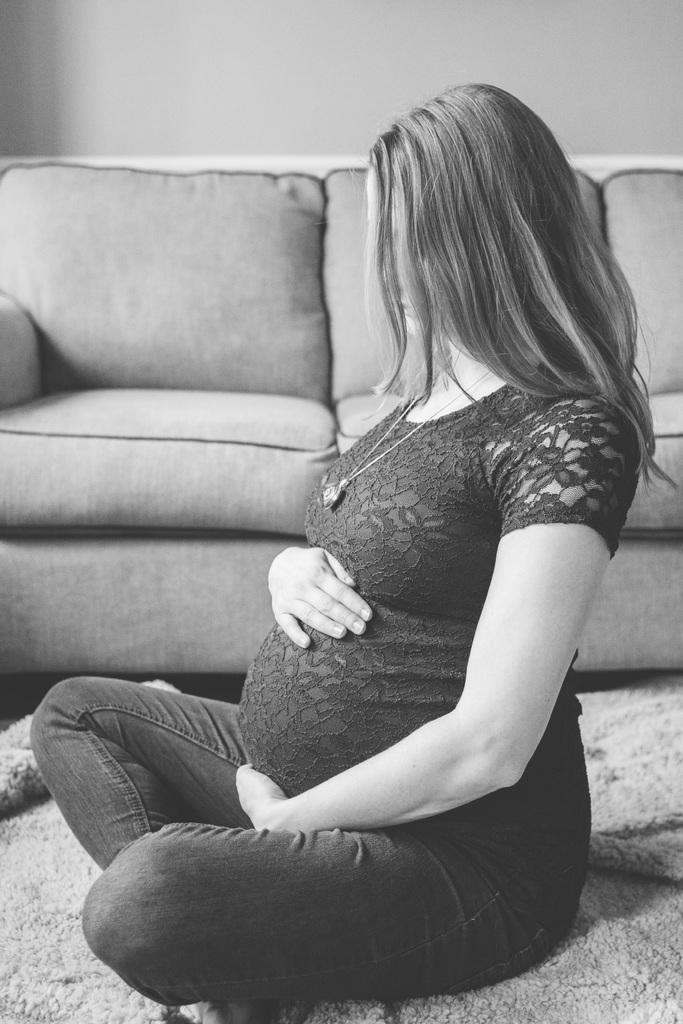Who is in the image? There is a woman in the image. What is the woman doing in the image? The woman is sitting on the floor. What is a notable detail about the woman in the image? The woman is pregnant. What is located behind the woman in the image? There is a sofa behind the woman, and a wall behind the sofa. How many apples are on the floor next to the woman in the image? There are no apples present in the image. Are there any dogs visible in the image? There are no dogs present in the image. 